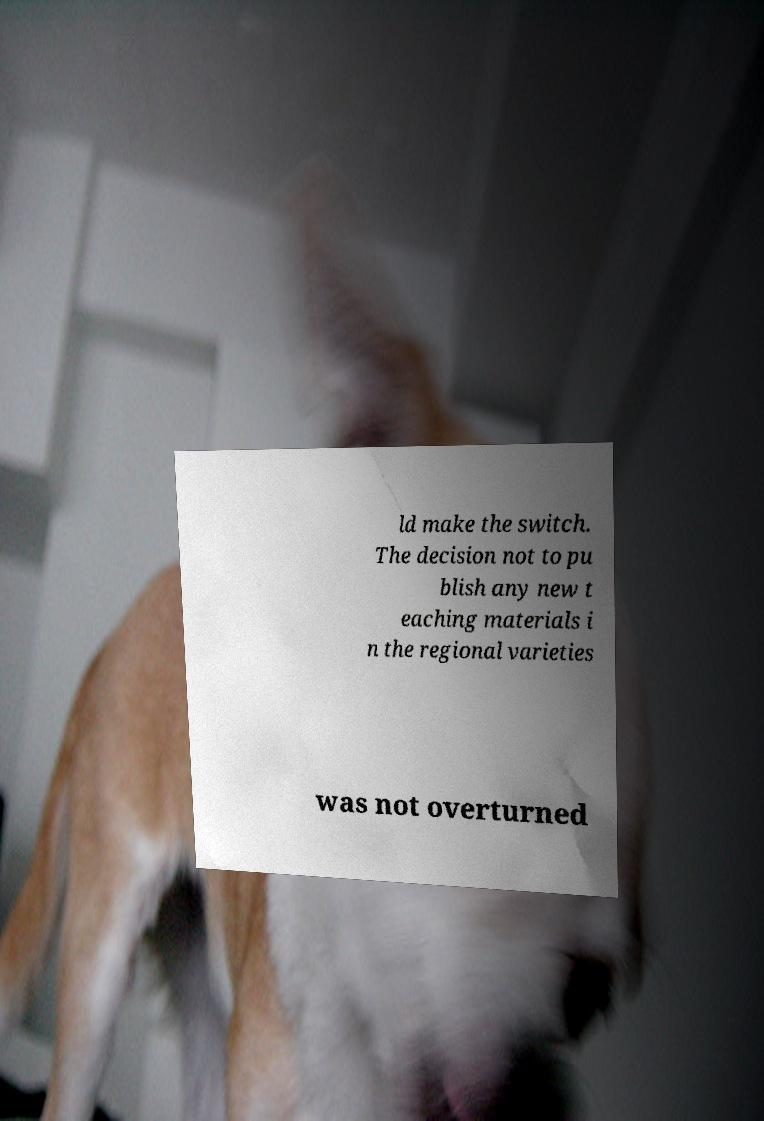Please identify and transcribe the text found in this image. ld make the switch. The decision not to pu blish any new t eaching materials i n the regional varieties was not overturned 